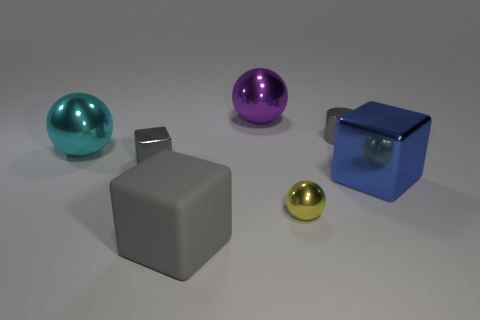Are there any other things that have the same material as the large gray block?
Your answer should be compact. No. There is a small shiny thing that is the same shape as the rubber object; what color is it?
Make the answer very short. Gray. Is the tiny cube made of the same material as the yellow ball?
Give a very brief answer. Yes. How many spheres are either big brown matte objects or gray things?
Keep it short and to the point. 0. There is a metal cube that is in front of the metal block on the left side of the big sphere that is on the right side of the cyan metallic sphere; what size is it?
Offer a very short reply. Large. What size is the purple object that is the same shape as the large cyan metallic thing?
Offer a terse response. Large. There is a big blue metal block; how many matte objects are behind it?
Your answer should be very brief. 0. There is a shiny cube on the left side of the large gray rubber cube; is it the same color as the cylinder?
Keep it short and to the point. Yes. How many cyan objects are either small balls or large shiny blocks?
Make the answer very short. 0. What is the color of the large cube that is to the right of the cube in front of the yellow shiny ball?
Your answer should be very brief. Blue. 